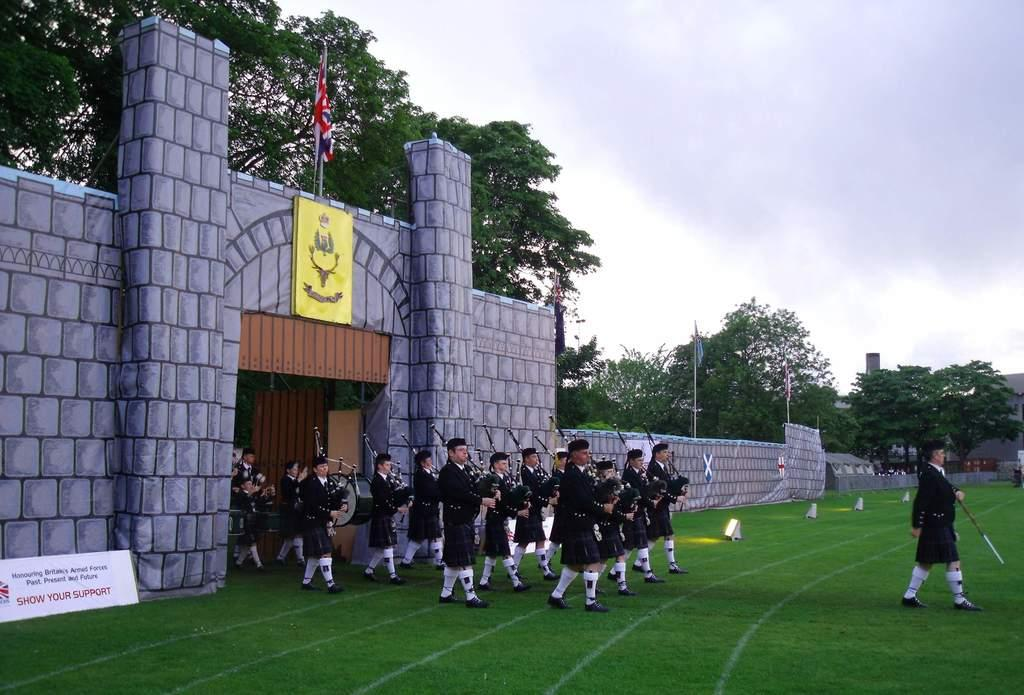<image>
Render a clear and concise summary of the photo. Marching band marching out in front of a sign which says Show Your Support. 